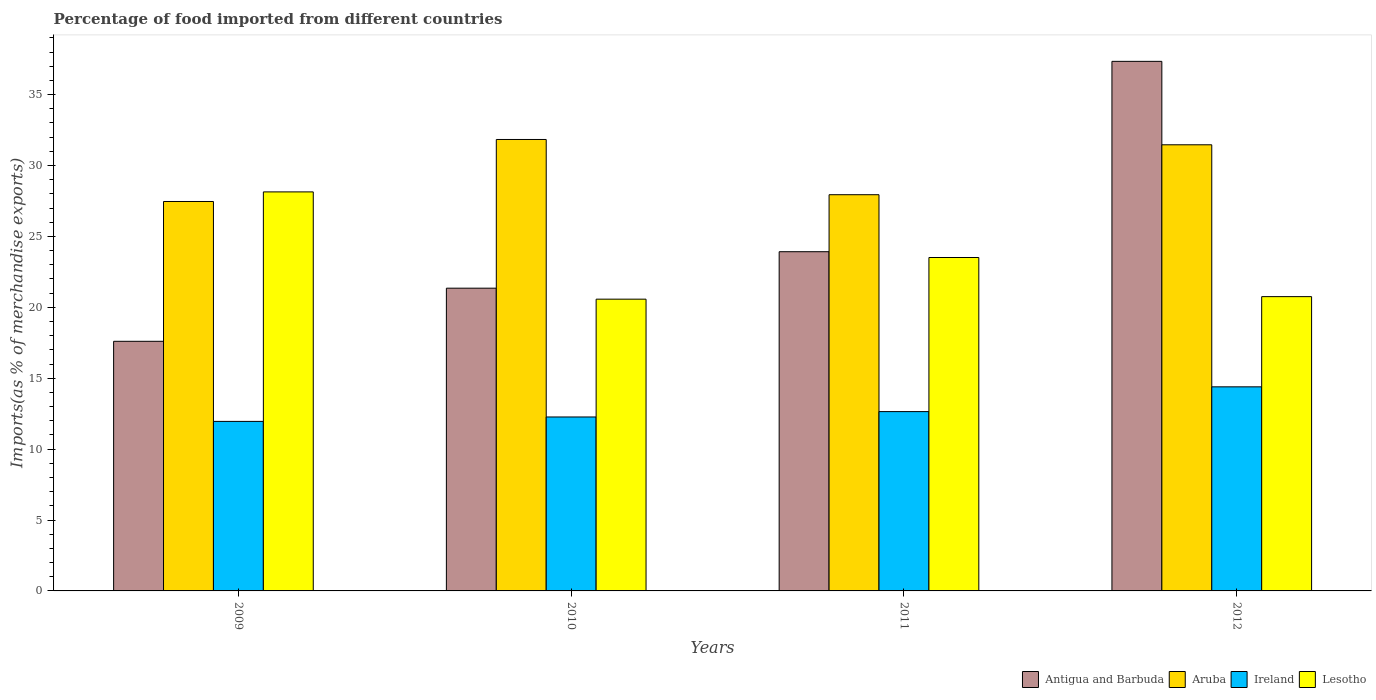How many different coloured bars are there?
Keep it short and to the point. 4. How many groups of bars are there?
Keep it short and to the point. 4. Are the number of bars per tick equal to the number of legend labels?
Your answer should be compact. Yes. Are the number of bars on each tick of the X-axis equal?
Your answer should be very brief. Yes. How many bars are there on the 2nd tick from the left?
Keep it short and to the point. 4. How many bars are there on the 1st tick from the right?
Give a very brief answer. 4. What is the percentage of imports to different countries in Aruba in 2009?
Offer a terse response. 27.46. Across all years, what is the maximum percentage of imports to different countries in Antigua and Barbuda?
Your answer should be very brief. 37.34. Across all years, what is the minimum percentage of imports to different countries in Aruba?
Give a very brief answer. 27.46. In which year was the percentage of imports to different countries in Antigua and Barbuda minimum?
Ensure brevity in your answer.  2009. What is the total percentage of imports to different countries in Aruba in the graph?
Provide a short and direct response. 118.69. What is the difference between the percentage of imports to different countries in Antigua and Barbuda in 2011 and that in 2012?
Provide a short and direct response. -13.42. What is the difference between the percentage of imports to different countries in Ireland in 2010 and the percentage of imports to different countries in Lesotho in 2009?
Ensure brevity in your answer.  -15.87. What is the average percentage of imports to different countries in Ireland per year?
Your answer should be very brief. 12.81. In the year 2011, what is the difference between the percentage of imports to different countries in Aruba and percentage of imports to different countries in Lesotho?
Ensure brevity in your answer.  4.43. What is the ratio of the percentage of imports to different countries in Lesotho in 2010 to that in 2011?
Make the answer very short. 0.88. Is the difference between the percentage of imports to different countries in Aruba in 2011 and 2012 greater than the difference between the percentage of imports to different countries in Lesotho in 2011 and 2012?
Offer a very short reply. No. What is the difference between the highest and the second highest percentage of imports to different countries in Antigua and Barbuda?
Ensure brevity in your answer.  13.42. What is the difference between the highest and the lowest percentage of imports to different countries in Lesotho?
Your answer should be compact. 7.56. In how many years, is the percentage of imports to different countries in Ireland greater than the average percentage of imports to different countries in Ireland taken over all years?
Offer a terse response. 1. Is the sum of the percentage of imports to different countries in Antigua and Barbuda in 2010 and 2011 greater than the maximum percentage of imports to different countries in Lesotho across all years?
Make the answer very short. Yes. What does the 2nd bar from the left in 2010 represents?
Your response must be concise. Aruba. What does the 2nd bar from the right in 2010 represents?
Provide a succinct answer. Ireland. Is it the case that in every year, the sum of the percentage of imports to different countries in Aruba and percentage of imports to different countries in Ireland is greater than the percentage of imports to different countries in Lesotho?
Give a very brief answer. Yes. How many bars are there?
Give a very brief answer. 16. How many years are there in the graph?
Your answer should be very brief. 4. What is the difference between two consecutive major ticks on the Y-axis?
Your answer should be very brief. 5. Are the values on the major ticks of Y-axis written in scientific E-notation?
Your answer should be compact. No. Does the graph contain any zero values?
Your answer should be very brief. No. Does the graph contain grids?
Your response must be concise. No. Where does the legend appear in the graph?
Provide a succinct answer. Bottom right. How many legend labels are there?
Give a very brief answer. 4. What is the title of the graph?
Your response must be concise. Percentage of food imported from different countries. What is the label or title of the Y-axis?
Provide a succinct answer. Imports(as % of merchandise exports). What is the Imports(as % of merchandise exports) in Antigua and Barbuda in 2009?
Make the answer very short. 17.6. What is the Imports(as % of merchandise exports) in Aruba in 2009?
Make the answer very short. 27.46. What is the Imports(as % of merchandise exports) in Ireland in 2009?
Your response must be concise. 11.95. What is the Imports(as % of merchandise exports) of Lesotho in 2009?
Give a very brief answer. 28.14. What is the Imports(as % of merchandise exports) of Antigua and Barbuda in 2010?
Your answer should be very brief. 21.35. What is the Imports(as % of merchandise exports) of Aruba in 2010?
Offer a very short reply. 31.83. What is the Imports(as % of merchandise exports) in Ireland in 2010?
Your answer should be compact. 12.27. What is the Imports(as % of merchandise exports) of Lesotho in 2010?
Ensure brevity in your answer.  20.57. What is the Imports(as % of merchandise exports) of Antigua and Barbuda in 2011?
Make the answer very short. 23.92. What is the Imports(as % of merchandise exports) in Aruba in 2011?
Provide a short and direct response. 27.94. What is the Imports(as % of merchandise exports) in Ireland in 2011?
Offer a terse response. 12.64. What is the Imports(as % of merchandise exports) of Lesotho in 2011?
Your response must be concise. 23.51. What is the Imports(as % of merchandise exports) of Antigua and Barbuda in 2012?
Make the answer very short. 37.34. What is the Imports(as % of merchandise exports) in Aruba in 2012?
Your response must be concise. 31.46. What is the Imports(as % of merchandise exports) of Ireland in 2012?
Your answer should be very brief. 14.39. What is the Imports(as % of merchandise exports) of Lesotho in 2012?
Your answer should be compact. 20.75. Across all years, what is the maximum Imports(as % of merchandise exports) in Antigua and Barbuda?
Provide a short and direct response. 37.34. Across all years, what is the maximum Imports(as % of merchandise exports) of Aruba?
Ensure brevity in your answer.  31.83. Across all years, what is the maximum Imports(as % of merchandise exports) of Ireland?
Provide a succinct answer. 14.39. Across all years, what is the maximum Imports(as % of merchandise exports) of Lesotho?
Provide a succinct answer. 28.14. Across all years, what is the minimum Imports(as % of merchandise exports) of Antigua and Barbuda?
Offer a terse response. 17.6. Across all years, what is the minimum Imports(as % of merchandise exports) in Aruba?
Offer a very short reply. 27.46. Across all years, what is the minimum Imports(as % of merchandise exports) in Ireland?
Your response must be concise. 11.95. Across all years, what is the minimum Imports(as % of merchandise exports) of Lesotho?
Make the answer very short. 20.57. What is the total Imports(as % of merchandise exports) of Antigua and Barbuda in the graph?
Offer a terse response. 100.21. What is the total Imports(as % of merchandise exports) in Aruba in the graph?
Your response must be concise. 118.69. What is the total Imports(as % of merchandise exports) of Ireland in the graph?
Offer a terse response. 51.25. What is the total Imports(as % of merchandise exports) of Lesotho in the graph?
Keep it short and to the point. 92.97. What is the difference between the Imports(as % of merchandise exports) of Antigua and Barbuda in 2009 and that in 2010?
Make the answer very short. -3.75. What is the difference between the Imports(as % of merchandise exports) of Aruba in 2009 and that in 2010?
Offer a very short reply. -4.37. What is the difference between the Imports(as % of merchandise exports) of Ireland in 2009 and that in 2010?
Your response must be concise. -0.31. What is the difference between the Imports(as % of merchandise exports) in Lesotho in 2009 and that in 2010?
Your answer should be compact. 7.56. What is the difference between the Imports(as % of merchandise exports) in Antigua and Barbuda in 2009 and that in 2011?
Make the answer very short. -6.32. What is the difference between the Imports(as % of merchandise exports) in Aruba in 2009 and that in 2011?
Provide a short and direct response. -0.48. What is the difference between the Imports(as % of merchandise exports) in Ireland in 2009 and that in 2011?
Offer a terse response. -0.69. What is the difference between the Imports(as % of merchandise exports) of Lesotho in 2009 and that in 2011?
Your answer should be very brief. 4.63. What is the difference between the Imports(as % of merchandise exports) in Antigua and Barbuda in 2009 and that in 2012?
Provide a short and direct response. -19.74. What is the difference between the Imports(as % of merchandise exports) of Aruba in 2009 and that in 2012?
Keep it short and to the point. -4. What is the difference between the Imports(as % of merchandise exports) of Ireland in 2009 and that in 2012?
Provide a succinct answer. -2.44. What is the difference between the Imports(as % of merchandise exports) in Lesotho in 2009 and that in 2012?
Offer a very short reply. 7.39. What is the difference between the Imports(as % of merchandise exports) in Antigua and Barbuda in 2010 and that in 2011?
Offer a terse response. -2.57. What is the difference between the Imports(as % of merchandise exports) of Aruba in 2010 and that in 2011?
Provide a succinct answer. 3.89. What is the difference between the Imports(as % of merchandise exports) of Ireland in 2010 and that in 2011?
Offer a very short reply. -0.38. What is the difference between the Imports(as % of merchandise exports) of Lesotho in 2010 and that in 2011?
Offer a terse response. -2.94. What is the difference between the Imports(as % of merchandise exports) in Antigua and Barbuda in 2010 and that in 2012?
Provide a short and direct response. -15.99. What is the difference between the Imports(as % of merchandise exports) in Aruba in 2010 and that in 2012?
Your response must be concise. 0.37. What is the difference between the Imports(as % of merchandise exports) in Ireland in 2010 and that in 2012?
Provide a succinct answer. -2.13. What is the difference between the Imports(as % of merchandise exports) in Lesotho in 2010 and that in 2012?
Your answer should be compact. -0.18. What is the difference between the Imports(as % of merchandise exports) of Antigua and Barbuda in 2011 and that in 2012?
Give a very brief answer. -13.42. What is the difference between the Imports(as % of merchandise exports) of Aruba in 2011 and that in 2012?
Give a very brief answer. -3.52. What is the difference between the Imports(as % of merchandise exports) of Ireland in 2011 and that in 2012?
Your answer should be compact. -1.75. What is the difference between the Imports(as % of merchandise exports) of Lesotho in 2011 and that in 2012?
Your answer should be compact. 2.76. What is the difference between the Imports(as % of merchandise exports) of Antigua and Barbuda in 2009 and the Imports(as % of merchandise exports) of Aruba in 2010?
Offer a terse response. -14.23. What is the difference between the Imports(as % of merchandise exports) of Antigua and Barbuda in 2009 and the Imports(as % of merchandise exports) of Ireland in 2010?
Offer a terse response. 5.34. What is the difference between the Imports(as % of merchandise exports) in Antigua and Barbuda in 2009 and the Imports(as % of merchandise exports) in Lesotho in 2010?
Your answer should be very brief. -2.97. What is the difference between the Imports(as % of merchandise exports) in Aruba in 2009 and the Imports(as % of merchandise exports) in Ireland in 2010?
Offer a very short reply. 15.19. What is the difference between the Imports(as % of merchandise exports) of Aruba in 2009 and the Imports(as % of merchandise exports) of Lesotho in 2010?
Your response must be concise. 6.89. What is the difference between the Imports(as % of merchandise exports) of Ireland in 2009 and the Imports(as % of merchandise exports) of Lesotho in 2010?
Your answer should be compact. -8.62. What is the difference between the Imports(as % of merchandise exports) in Antigua and Barbuda in 2009 and the Imports(as % of merchandise exports) in Aruba in 2011?
Give a very brief answer. -10.34. What is the difference between the Imports(as % of merchandise exports) in Antigua and Barbuda in 2009 and the Imports(as % of merchandise exports) in Ireland in 2011?
Your response must be concise. 4.96. What is the difference between the Imports(as % of merchandise exports) of Antigua and Barbuda in 2009 and the Imports(as % of merchandise exports) of Lesotho in 2011?
Offer a very short reply. -5.91. What is the difference between the Imports(as % of merchandise exports) in Aruba in 2009 and the Imports(as % of merchandise exports) in Ireland in 2011?
Offer a very short reply. 14.82. What is the difference between the Imports(as % of merchandise exports) in Aruba in 2009 and the Imports(as % of merchandise exports) in Lesotho in 2011?
Make the answer very short. 3.95. What is the difference between the Imports(as % of merchandise exports) in Ireland in 2009 and the Imports(as % of merchandise exports) in Lesotho in 2011?
Offer a terse response. -11.56. What is the difference between the Imports(as % of merchandise exports) of Antigua and Barbuda in 2009 and the Imports(as % of merchandise exports) of Aruba in 2012?
Make the answer very short. -13.86. What is the difference between the Imports(as % of merchandise exports) in Antigua and Barbuda in 2009 and the Imports(as % of merchandise exports) in Ireland in 2012?
Offer a terse response. 3.21. What is the difference between the Imports(as % of merchandise exports) of Antigua and Barbuda in 2009 and the Imports(as % of merchandise exports) of Lesotho in 2012?
Your response must be concise. -3.15. What is the difference between the Imports(as % of merchandise exports) in Aruba in 2009 and the Imports(as % of merchandise exports) in Ireland in 2012?
Provide a short and direct response. 13.07. What is the difference between the Imports(as % of merchandise exports) of Aruba in 2009 and the Imports(as % of merchandise exports) of Lesotho in 2012?
Your answer should be compact. 6.71. What is the difference between the Imports(as % of merchandise exports) in Ireland in 2009 and the Imports(as % of merchandise exports) in Lesotho in 2012?
Provide a succinct answer. -8.8. What is the difference between the Imports(as % of merchandise exports) in Antigua and Barbuda in 2010 and the Imports(as % of merchandise exports) in Aruba in 2011?
Ensure brevity in your answer.  -6.59. What is the difference between the Imports(as % of merchandise exports) in Antigua and Barbuda in 2010 and the Imports(as % of merchandise exports) in Ireland in 2011?
Ensure brevity in your answer.  8.7. What is the difference between the Imports(as % of merchandise exports) of Antigua and Barbuda in 2010 and the Imports(as % of merchandise exports) of Lesotho in 2011?
Provide a succinct answer. -2.16. What is the difference between the Imports(as % of merchandise exports) of Aruba in 2010 and the Imports(as % of merchandise exports) of Ireland in 2011?
Your answer should be compact. 19.19. What is the difference between the Imports(as % of merchandise exports) of Aruba in 2010 and the Imports(as % of merchandise exports) of Lesotho in 2011?
Make the answer very short. 8.32. What is the difference between the Imports(as % of merchandise exports) in Ireland in 2010 and the Imports(as % of merchandise exports) in Lesotho in 2011?
Offer a very short reply. -11.24. What is the difference between the Imports(as % of merchandise exports) in Antigua and Barbuda in 2010 and the Imports(as % of merchandise exports) in Aruba in 2012?
Offer a very short reply. -10.11. What is the difference between the Imports(as % of merchandise exports) of Antigua and Barbuda in 2010 and the Imports(as % of merchandise exports) of Ireland in 2012?
Offer a terse response. 6.96. What is the difference between the Imports(as % of merchandise exports) of Antigua and Barbuda in 2010 and the Imports(as % of merchandise exports) of Lesotho in 2012?
Your answer should be very brief. 0.6. What is the difference between the Imports(as % of merchandise exports) of Aruba in 2010 and the Imports(as % of merchandise exports) of Ireland in 2012?
Your answer should be compact. 17.44. What is the difference between the Imports(as % of merchandise exports) of Aruba in 2010 and the Imports(as % of merchandise exports) of Lesotho in 2012?
Offer a terse response. 11.08. What is the difference between the Imports(as % of merchandise exports) of Ireland in 2010 and the Imports(as % of merchandise exports) of Lesotho in 2012?
Provide a short and direct response. -8.49. What is the difference between the Imports(as % of merchandise exports) of Antigua and Barbuda in 2011 and the Imports(as % of merchandise exports) of Aruba in 2012?
Your response must be concise. -7.54. What is the difference between the Imports(as % of merchandise exports) of Antigua and Barbuda in 2011 and the Imports(as % of merchandise exports) of Ireland in 2012?
Provide a short and direct response. 9.53. What is the difference between the Imports(as % of merchandise exports) in Antigua and Barbuda in 2011 and the Imports(as % of merchandise exports) in Lesotho in 2012?
Your answer should be very brief. 3.17. What is the difference between the Imports(as % of merchandise exports) in Aruba in 2011 and the Imports(as % of merchandise exports) in Ireland in 2012?
Make the answer very short. 13.55. What is the difference between the Imports(as % of merchandise exports) in Aruba in 2011 and the Imports(as % of merchandise exports) in Lesotho in 2012?
Provide a short and direct response. 7.19. What is the difference between the Imports(as % of merchandise exports) in Ireland in 2011 and the Imports(as % of merchandise exports) in Lesotho in 2012?
Keep it short and to the point. -8.11. What is the average Imports(as % of merchandise exports) of Antigua and Barbuda per year?
Ensure brevity in your answer.  25.05. What is the average Imports(as % of merchandise exports) in Aruba per year?
Your answer should be compact. 29.67. What is the average Imports(as % of merchandise exports) of Ireland per year?
Offer a very short reply. 12.81. What is the average Imports(as % of merchandise exports) in Lesotho per year?
Give a very brief answer. 23.24. In the year 2009, what is the difference between the Imports(as % of merchandise exports) of Antigua and Barbuda and Imports(as % of merchandise exports) of Aruba?
Provide a succinct answer. -9.86. In the year 2009, what is the difference between the Imports(as % of merchandise exports) of Antigua and Barbuda and Imports(as % of merchandise exports) of Ireland?
Provide a short and direct response. 5.65. In the year 2009, what is the difference between the Imports(as % of merchandise exports) of Antigua and Barbuda and Imports(as % of merchandise exports) of Lesotho?
Provide a succinct answer. -10.53. In the year 2009, what is the difference between the Imports(as % of merchandise exports) of Aruba and Imports(as % of merchandise exports) of Ireland?
Offer a very short reply. 15.51. In the year 2009, what is the difference between the Imports(as % of merchandise exports) in Aruba and Imports(as % of merchandise exports) in Lesotho?
Offer a terse response. -0.68. In the year 2009, what is the difference between the Imports(as % of merchandise exports) in Ireland and Imports(as % of merchandise exports) in Lesotho?
Offer a terse response. -16.18. In the year 2010, what is the difference between the Imports(as % of merchandise exports) in Antigua and Barbuda and Imports(as % of merchandise exports) in Aruba?
Your answer should be compact. -10.49. In the year 2010, what is the difference between the Imports(as % of merchandise exports) in Antigua and Barbuda and Imports(as % of merchandise exports) in Ireland?
Your answer should be very brief. 9.08. In the year 2010, what is the difference between the Imports(as % of merchandise exports) of Antigua and Barbuda and Imports(as % of merchandise exports) of Lesotho?
Provide a short and direct response. 0.77. In the year 2010, what is the difference between the Imports(as % of merchandise exports) of Aruba and Imports(as % of merchandise exports) of Ireland?
Your response must be concise. 19.57. In the year 2010, what is the difference between the Imports(as % of merchandise exports) in Aruba and Imports(as % of merchandise exports) in Lesotho?
Make the answer very short. 11.26. In the year 2010, what is the difference between the Imports(as % of merchandise exports) of Ireland and Imports(as % of merchandise exports) of Lesotho?
Your answer should be compact. -8.31. In the year 2011, what is the difference between the Imports(as % of merchandise exports) in Antigua and Barbuda and Imports(as % of merchandise exports) in Aruba?
Provide a short and direct response. -4.02. In the year 2011, what is the difference between the Imports(as % of merchandise exports) of Antigua and Barbuda and Imports(as % of merchandise exports) of Ireland?
Your response must be concise. 11.27. In the year 2011, what is the difference between the Imports(as % of merchandise exports) of Antigua and Barbuda and Imports(as % of merchandise exports) of Lesotho?
Keep it short and to the point. 0.41. In the year 2011, what is the difference between the Imports(as % of merchandise exports) in Aruba and Imports(as % of merchandise exports) in Ireland?
Your response must be concise. 15.29. In the year 2011, what is the difference between the Imports(as % of merchandise exports) in Aruba and Imports(as % of merchandise exports) in Lesotho?
Your response must be concise. 4.43. In the year 2011, what is the difference between the Imports(as % of merchandise exports) of Ireland and Imports(as % of merchandise exports) of Lesotho?
Keep it short and to the point. -10.87. In the year 2012, what is the difference between the Imports(as % of merchandise exports) in Antigua and Barbuda and Imports(as % of merchandise exports) in Aruba?
Offer a very short reply. 5.88. In the year 2012, what is the difference between the Imports(as % of merchandise exports) of Antigua and Barbuda and Imports(as % of merchandise exports) of Ireland?
Offer a very short reply. 22.95. In the year 2012, what is the difference between the Imports(as % of merchandise exports) in Antigua and Barbuda and Imports(as % of merchandise exports) in Lesotho?
Offer a terse response. 16.59. In the year 2012, what is the difference between the Imports(as % of merchandise exports) of Aruba and Imports(as % of merchandise exports) of Ireland?
Your response must be concise. 17.07. In the year 2012, what is the difference between the Imports(as % of merchandise exports) of Aruba and Imports(as % of merchandise exports) of Lesotho?
Provide a short and direct response. 10.71. In the year 2012, what is the difference between the Imports(as % of merchandise exports) in Ireland and Imports(as % of merchandise exports) in Lesotho?
Keep it short and to the point. -6.36. What is the ratio of the Imports(as % of merchandise exports) of Antigua and Barbuda in 2009 to that in 2010?
Offer a terse response. 0.82. What is the ratio of the Imports(as % of merchandise exports) of Aruba in 2009 to that in 2010?
Offer a terse response. 0.86. What is the ratio of the Imports(as % of merchandise exports) in Ireland in 2009 to that in 2010?
Offer a very short reply. 0.97. What is the ratio of the Imports(as % of merchandise exports) in Lesotho in 2009 to that in 2010?
Provide a short and direct response. 1.37. What is the ratio of the Imports(as % of merchandise exports) in Antigua and Barbuda in 2009 to that in 2011?
Your answer should be compact. 0.74. What is the ratio of the Imports(as % of merchandise exports) of Aruba in 2009 to that in 2011?
Provide a short and direct response. 0.98. What is the ratio of the Imports(as % of merchandise exports) of Ireland in 2009 to that in 2011?
Give a very brief answer. 0.95. What is the ratio of the Imports(as % of merchandise exports) in Lesotho in 2009 to that in 2011?
Offer a terse response. 1.2. What is the ratio of the Imports(as % of merchandise exports) of Antigua and Barbuda in 2009 to that in 2012?
Ensure brevity in your answer.  0.47. What is the ratio of the Imports(as % of merchandise exports) of Aruba in 2009 to that in 2012?
Keep it short and to the point. 0.87. What is the ratio of the Imports(as % of merchandise exports) of Ireland in 2009 to that in 2012?
Your answer should be very brief. 0.83. What is the ratio of the Imports(as % of merchandise exports) in Lesotho in 2009 to that in 2012?
Provide a short and direct response. 1.36. What is the ratio of the Imports(as % of merchandise exports) of Antigua and Barbuda in 2010 to that in 2011?
Offer a terse response. 0.89. What is the ratio of the Imports(as % of merchandise exports) in Aruba in 2010 to that in 2011?
Keep it short and to the point. 1.14. What is the ratio of the Imports(as % of merchandise exports) of Ireland in 2010 to that in 2011?
Make the answer very short. 0.97. What is the ratio of the Imports(as % of merchandise exports) in Lesotho in 2010 to that in 2011?
Provide a succinct answer. 0.88. What is the ratio of the Imports(as % of merchandise exports) in Antigua and Barbuda in 2010 to that in 2012?
Ensure brevity in your answer.  0.57. What is the ratio of the Imports(as % of merchandise exports) in Aruba in 2010 to that in 2012?
Provide a succinct answer. 1.01. What is the ratio of the Imports(as % of merchandise exports) of Ireland in 2010 to that in 2012?
Provide a short and direct response. 0.85. What is the ratio of the Imports(as % of merchandise exports) in Lesotho in 2010 to that in 2012?
Make the answer very short. 0.99. What is the ratio of the Imports(as % of merchandise exports) of Antigua and Barbuda in 2011 to that in 2012?
Give a very brief answer. 0.64. What is the ratio of the Imports(as % of merchandise exports) in Aruba in 2011 to that in 2012?
Keep it short and to the point. 0.89. What is the ratio of the Imports(as % of merchandise exports) in Ireland in 2011 to that in 2012?
Provide a succinct answer. 0.88. What is the ratio of the Imports(as % of merchandise exports) in Lesotho in 2011 to that in 2012?
Provide a short and direct response. 1.13. What is the difference between the highest and the second highest Imports(as % of merchandise exports) of Antigua and Barbuda?
Keep it short and to the point. 13.42. What is the difference between the highest and the second highest Imports(as % of merchandise exports) of Aruba?
Keep it short and to the point. 0.37. What is the difference between the highest and the second highest Imports(as % of merchandise exports) of Ireland?
Provide a succinct answer. 1.75. What is the difference between the highest and the second highest Imports(as % of merchandise exports) of Lesotho?
Offer a terse response. 4.63. What is the difference between the highest and the lowest Imports(as % of merchandise exports) of Antigua and Barbuda?
Your answer should be very brief. 19.74. What is the difference between the highest and the lowest Imports(as % of merchandise exports) of Aruba?
Offer a very short reply. 4.37. What is the difference between the highest and the lowest Imports(as % of merchandise exports) in Ireland?
Your answer should be compact. 2.44. What is the difference between the highest and the lowest Imports(as % of merchandise exports) in Lesotho?
Your answer should be very brief. 7.56. 